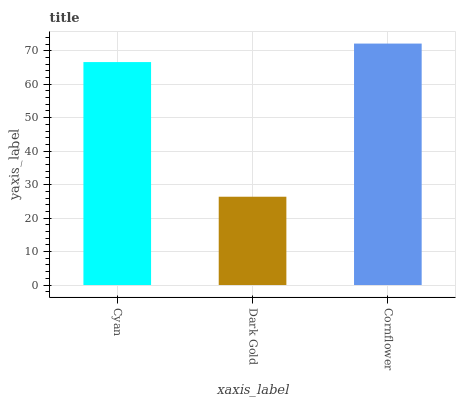Is Dark Gold the minimum?
Answer yes or no. Yes. Is Cornflower the maximum?
Answer yes or no. Yes. Is Cornflower the minimum?
Answer yes or no. No. Is Dark Gold the maximum?
Answer yes or no. No. Is Cornflower greater than Dark Gold?
Answer yes or no. Yes. Is Dark Gold less than Cornflower?
Answer yes or no. Yes. Is Dark Gold greater than Cornflower?
Answer yes or no. No. Is Cornflower less than Dark Gold?
Answer yes or no. No. Is Cyan the high median?
Answer yes or no. Yes. Is Cyan the low median?
Answer yes or no. Yes. Is Dark Gold the high median?
Answer yes or no. No. Is Cornflower the low median?
Answer yes or no. No. 